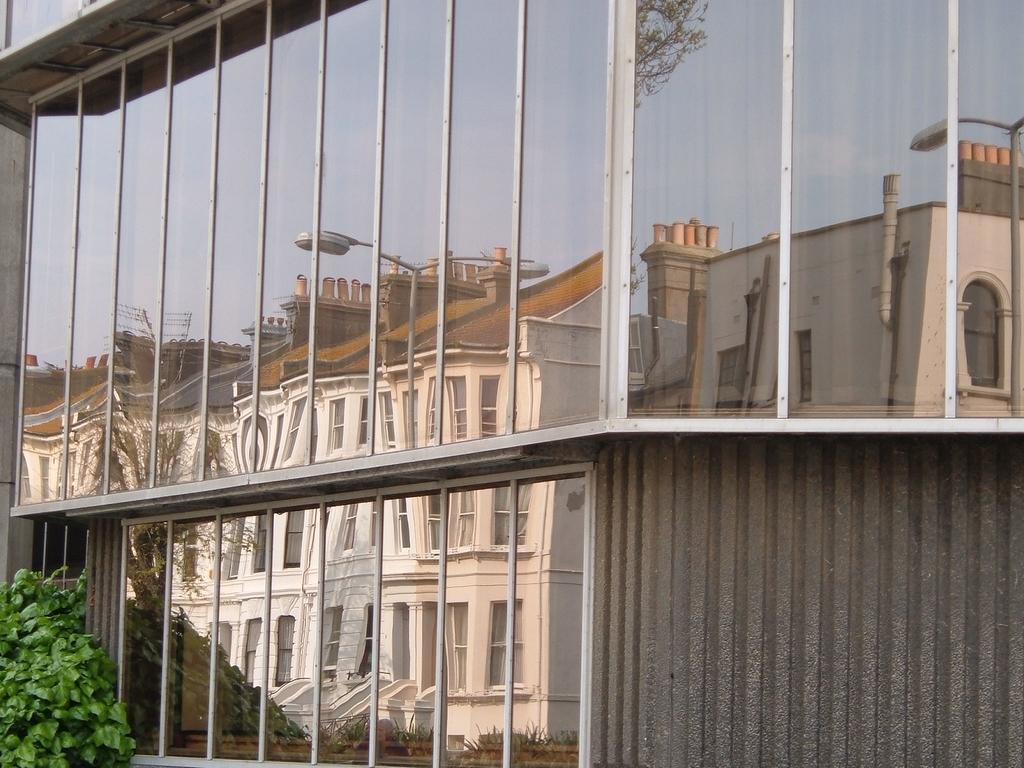How would you summarize this image in a sentence or two? In this image we can see a building with glass windows and in the reflection of the windows, one white color building is there. Left bottom of the image plant is present. 